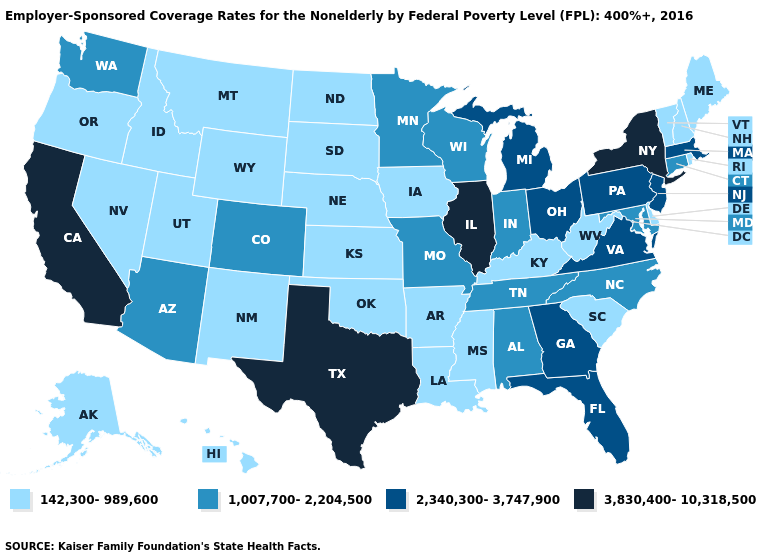What is the value of South Dakota?
Quick response, please. 142,300-989,600. Name the states that have a value in the range 142,300-989,600?
Concise answer only. Alaska, Arkansas, Delaware, Hawaii, Idaho, Iowa, Kansas, Kentucky, Louisiana, Maine, Mississippi, Montana, Nebraska, Nevada, New Hampshire, New Mexico, North Dakota, Oklahoma, Oregon, Rhode Island, South Carolina, South Dakota, Utah, Vermont, West Virginia, Wyoming. Which states have the lowest value in the USA?
Keep it brief. Alaska, Arkansas, Delaware, Hawaii, Idaho, Iowa, Kansas, Kentucky, Louisiana, Maine, Mississippi, Montana, Nebraska, Nevada, New Hampshire, New Mexico, North Dakota, Oklahoma, Oregon, Rhode Island, South Carolina, South Dakota, Utah, Vermont, West Virginia, Wyoming. Among the states that border Kentucky , which have the highest value?
Be succinct. Illinois. Which states have the lowest value in the USA?
Answer briefly. Alaska, Arkansas, Delaware, Hawaii, Idaho, Iowa, Kansas, Kentucky, Louisiana, Maine, Mississippi, Montana, Nebraska, Nevada, New Hampshire, New Mexico, North Dakota, Oklahoma, Oregon, Rhode Island, South Carolina, South Dakota, Utah, Vermont, West Virginia, Wyoming. What is the highest value in states that border Illinois?
Answer briefly. 1,007,700-2,204,500. Does the map have missing data?
Give a very brief answer. No. Name the states that have a value in the range 1,007,700-2,204,500?
Short answer required. Alabama, Arizona, Colorado, Connecticut, Indiana, Maryland, Minnesota, Missouri, North Carolina, Tennessee, Washington, Wisconsin. What is the value of Colorado?
Keep it brief. 1,007,700-2,204,500. Name the states that have a value in the range 1,007,700-2,204,500?
Answer briefly. Alabama, Arizona, Colorado, Connecticut, Indiana, Maryland, Minnesota, Missouri, North Carolina, Tennessee, Washington, Wisconsin. Name the states that have a value in the range 3,830,400-10,318,500?
Give a very brief answer. California, Illinois, New York, Texas. Name the states that have a value in the range 142,300-989,600?
Short answer required. Alaska, Arkansas, Delaware, Hawaii, Idaho, Iowa, Kansas, Kentucky, Louisiana, Maine, Mississippi, Montana, Nebraska, Nevada, New Hampshire, New Mexico, North Dakota, Oklahoma, Oregon, Rhode Island, South Carolina, South Dakota, Utah, Vermont, West Virginia, Wyoming. Is the legend a continuous bar?
Give a very brief answer. No. How many symbols are there in the legend?
Write a very short answer. 4. Does Georgia have the lowest value in the South?
Be succinct. No. 